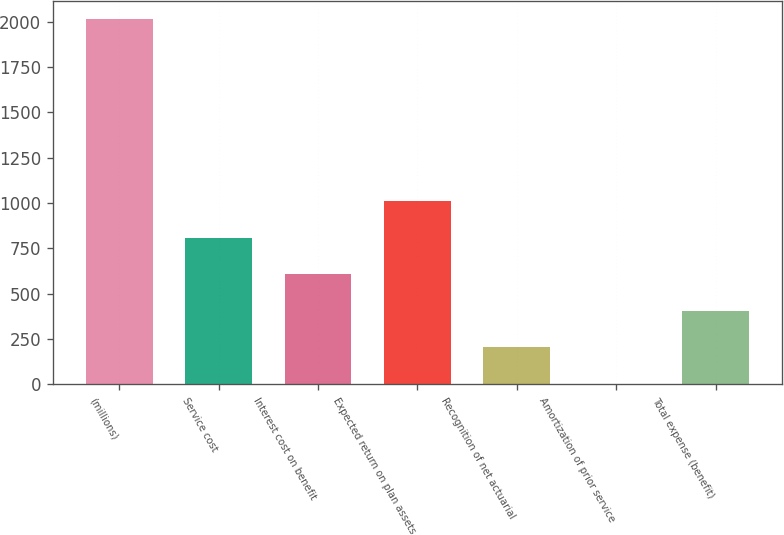Convert chart to OTSL. <chart><loc_0><loc_0><loc_500><loc_500><bar_chart><fcel>(millions)<fcel>Service cost<fcel>Interest cost on benefit<fcel>Expected return on plan assets<fcel>Recognition of net actuarial<fcel>Amortization of prior service<fcel>Total expense (benefit)<nl><fcel>2017<fcel>807.22<fcel>605.59<fcel>1008.85<fcel>202.33<fcel>0.7<fcel>403.96<nl></chart> 